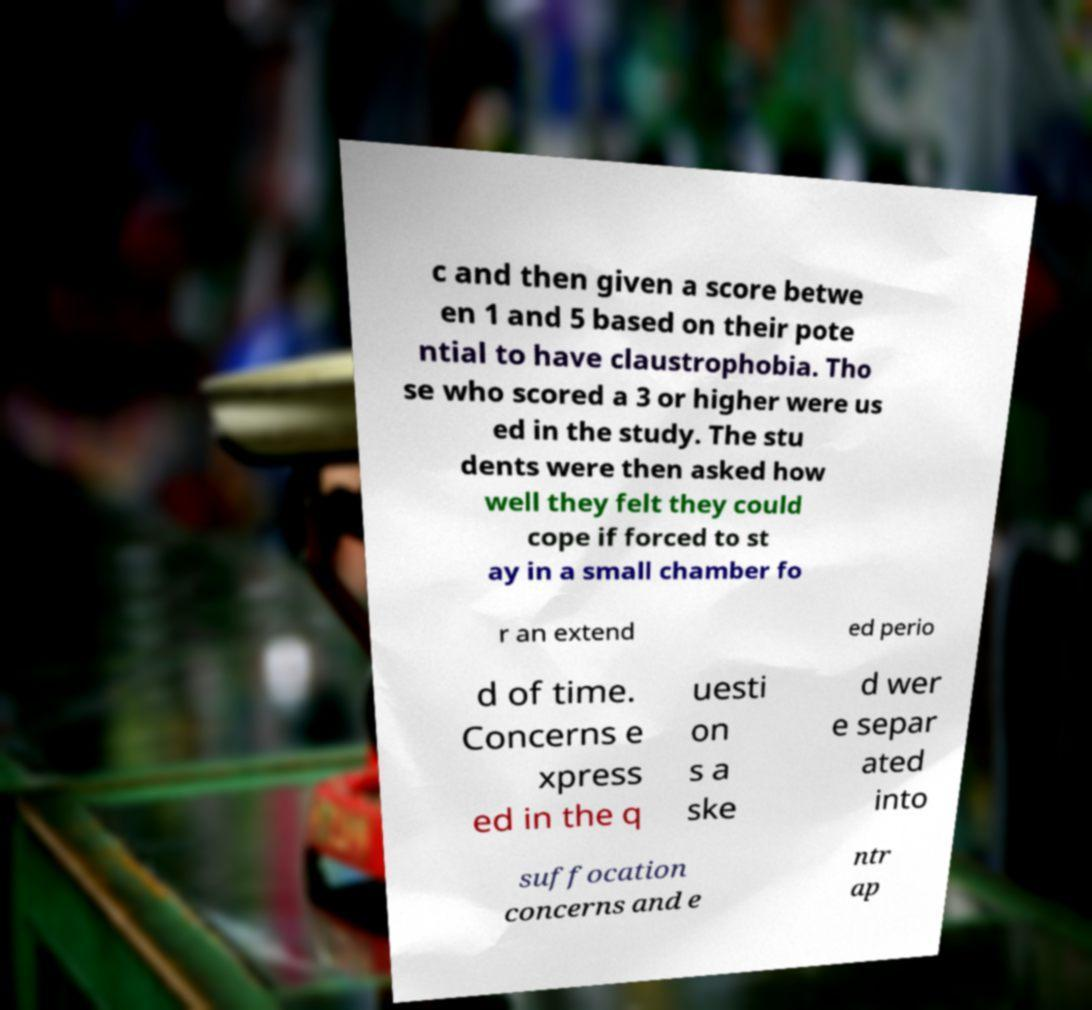For documentation purposes, I need the text within this image transcribed. Could you provide that? c and then given a score betwe en 1 and 5 based on their pote ntial to have claustrophobia. Tho se who scored a 3 or higher were us ed in the study. The stu dents were then asked how well they felt they could cope if forced to st ay in a small chamber fo r an extend ed perio d of time. Concerns e xpress ed in the q uesti on s a ske d wer e separ ated into suffocation concerns and e ntr ap 